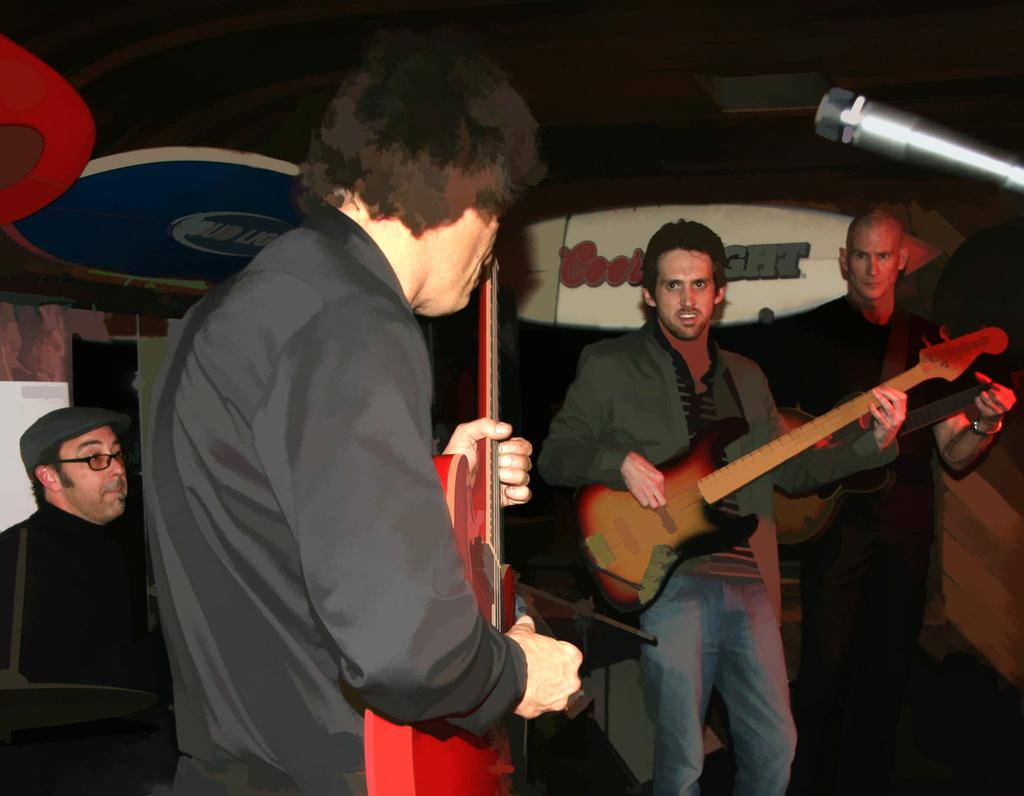How many people are in the image? There is a group of people in the image. What are the people in the image doing? The people are playing guitar. What can be seen in the background of the image? There is a board visible in the background of the image. What type of veil is draped over the guitar in the image? There is no veil present in the image; the people are simply playing guitar. 